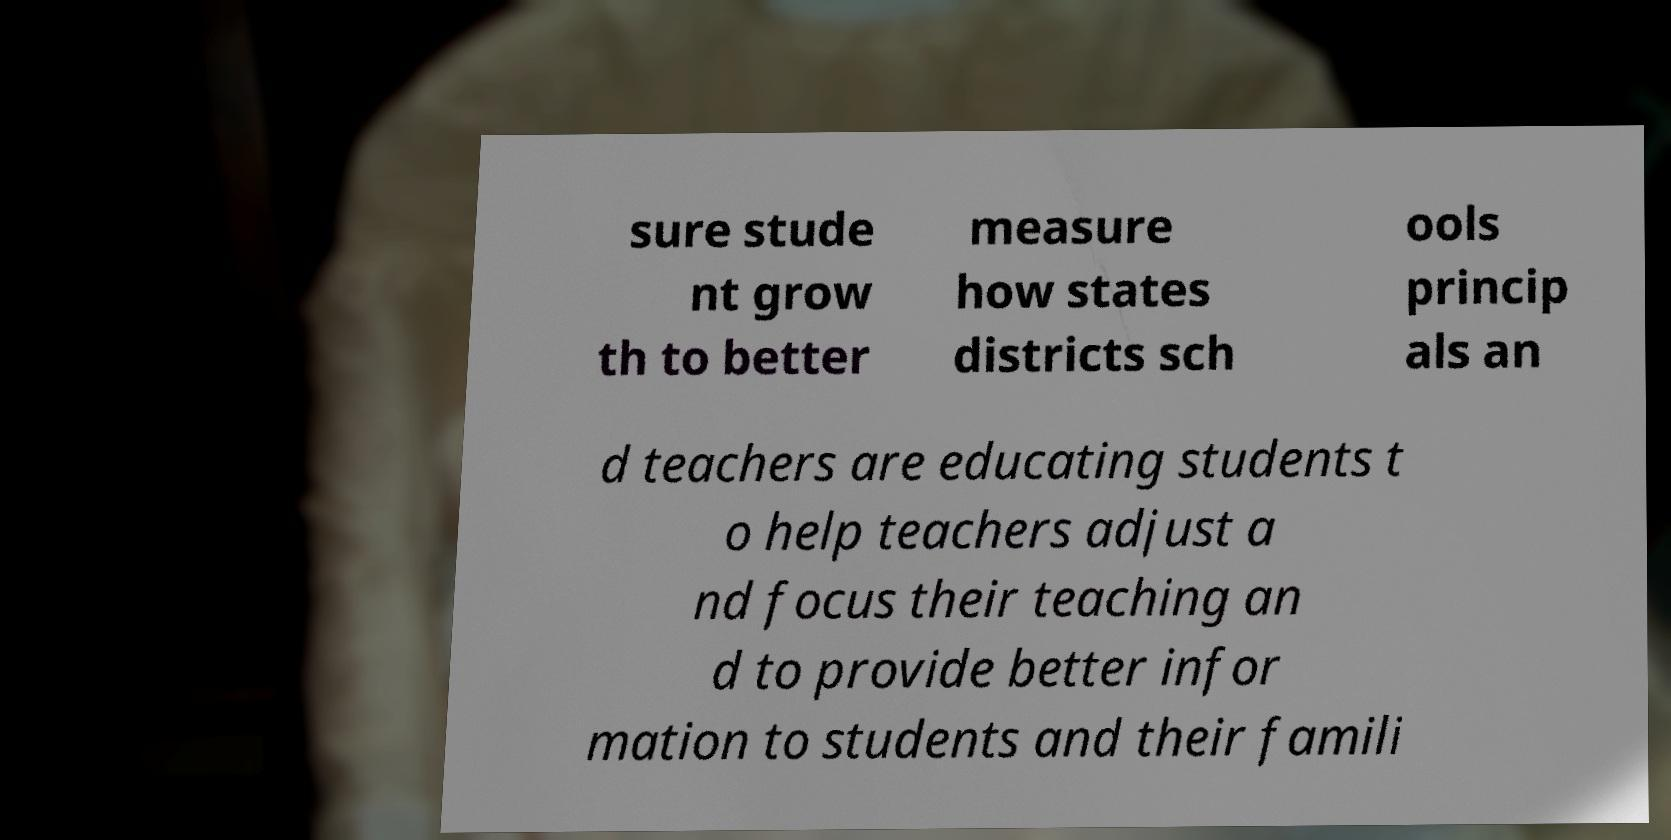Could you extract and type out the text from this image? sure stude nt grow th to better measure how states districts sch ools princip als an d teachers are educating students t o help teachers adjust a nd focus their teaching an d to provide better infor mation to students and their famili 